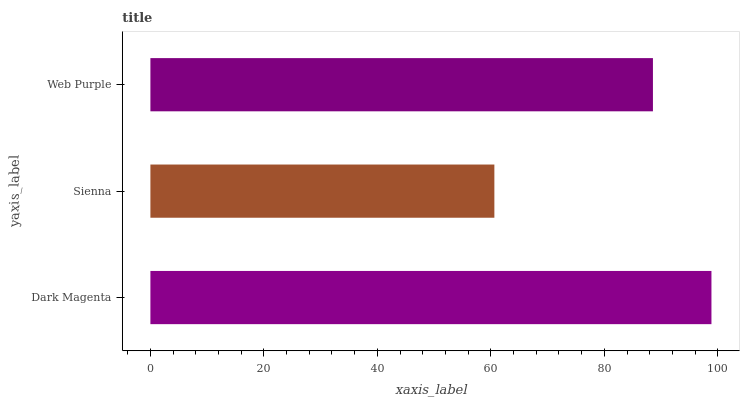Is Sienna the minimum?
Answer yes or no. Yes. Is Dark Magenta the maximum?
Answer yes or no. Yes. Is Web Purple the minimum?
Answer yes or no. No. Is Web Purple the maximum?
Answer yes or no. No. Is Web Purple greater than Sienna?
Answer yes or no. Yes. Is Sienna less than Web Purple?
Answer yes or no. Yes. Is Sienna greater than Web Purple?
Answer yes or no. No. Is Web Purple less than Sienna?
Answer yes or no. No. Is Web Purple the high median?
Answer yes or no. Yes. Is Web Purple the low median?
Answer yes or no. Yes. Is Sienna the high median?
Answer yes or no. No. Is Dark Magenta the low median?
Answer yes or no. No. 